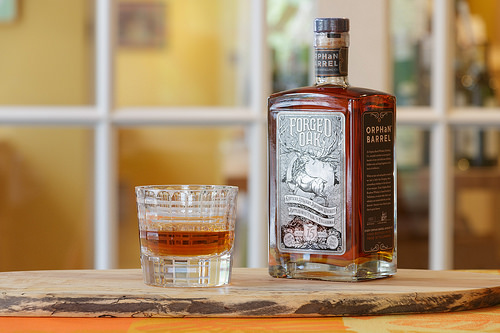<image>
Is there a rum above the table? No. The rum is not positioned above the table. The vertical arrangement shows a different relationship. 